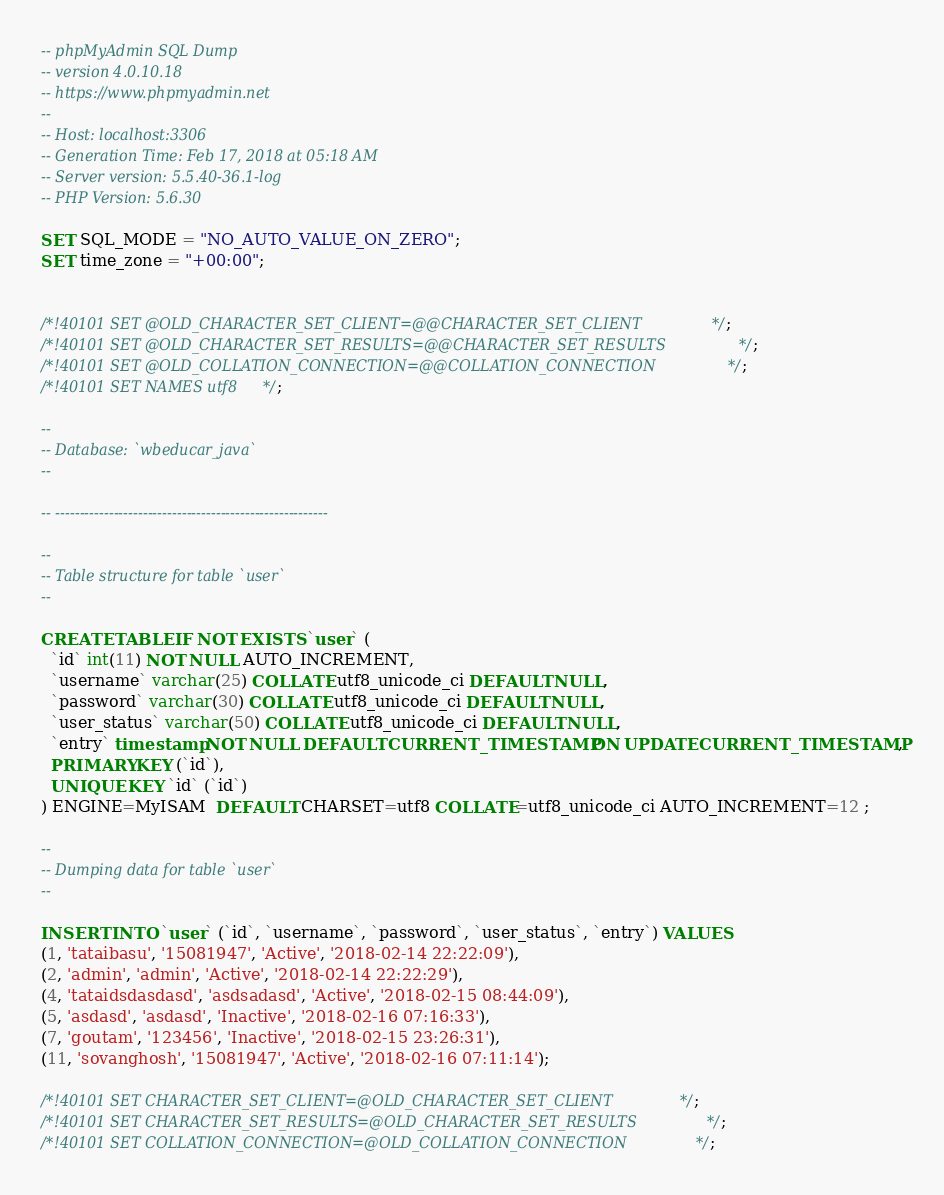Convert code to text. <code><loc_0><loc_0><loc_500><loc_500><_SQL_>-- phpMyAdmin SQL Dump
-- version 4.0.10.18
-- https://www.phpmyadmin.net
--
-- Host: localhost:3306
-- Generation Time: Feb 17, 2018 at 05:18 AM
-- Server version: 5.5.40-36.1-log
-- PHP Version: 5.6.30

SET SQL_MODE = "NO_AUTO_VALUE_ON_ZERO";
SET time_zone = "+00:00";


/*!40101 SET @OLD_CHARACTER_SET_CLIENT=@@CHARACTER_SET_CLIENT */;
/*!40101 SET @OLD_CHARACTER_SET_RESULTS=@@CHARACTER_SET_RESULTS */;
/*!40101 SET @OLD_COLLATION_CONNECTION=@@COLLATION_CONNECTION */;
/*!40101 SET NAMES utf8 */;

--
-- Database: `wbeducar_java`
--

-- --------------------------------------------------------

--
-- Table structure for table `user`
--

CREATE TABLE IF NOT EXISTS `user` (
  `id` int(11) NOT NULL AUTO_INCREMENT,
  `username` varchar(25) COLLATE utf8_unicode_ci DEFAULT NULL,
  `password` varchar(30) COLLATE utf8_unicode_ci DEFAULT NULL,
  `user_status` varchar(50) COLLATE utf8_unicode_ci DEFAULT NULL,
  `entry` timestamp NOT NULL DEFAULT CURRENT_TIMESTAMP ON UPDATE CURRENT_TIMESTAMP,
  PRIMARY KEY (`id`),
  UNIQUE KEY `id` (`id`)
) ENGINE=MyISAM  DEFAULT CHARSET=utf8 COLLATE=utf8_unicode_ci AUTO_INCREMENT=12 ;

--
-- Dumping data for table `user`
--

INSERT INTO `user` (`id`, `username`, `password`, `user_status`, `entry`) VALUES
(1, 'tataibasu', '15081947', 'Active', '2018-02-14 22:22:09'),
(2, 'admin', 'admin', 'Active', '2018-02-14 22:22:29'),
(4, 'tataidsdasdasd', 'asdsadasd', 'Active', '2018-02-15 08:44:09'),
(5, 'asdasd', 'asdasd', 'Inactive', '2018-02-16 07:16:33'),
(7, 'goutam', '123456', 'Inactive', '2018-02-15 23:26:31'),
(11, 'sovanghosh', '15081947', 'Active', '2018-02-16 07:11:14');

/*!40101 SET CHARACTER_SET_CLIENT=@OLD_CHARACTER_SET_CLIENT */;
/*!40101 SET CHARACTER_SET_RESULTS=@OLD_CHARACTER_SET_RESULTS */;
/*!40101 SET COLLATION_CONNECTION=@OLD_COLLATION_CONNECTION */;
</code> 